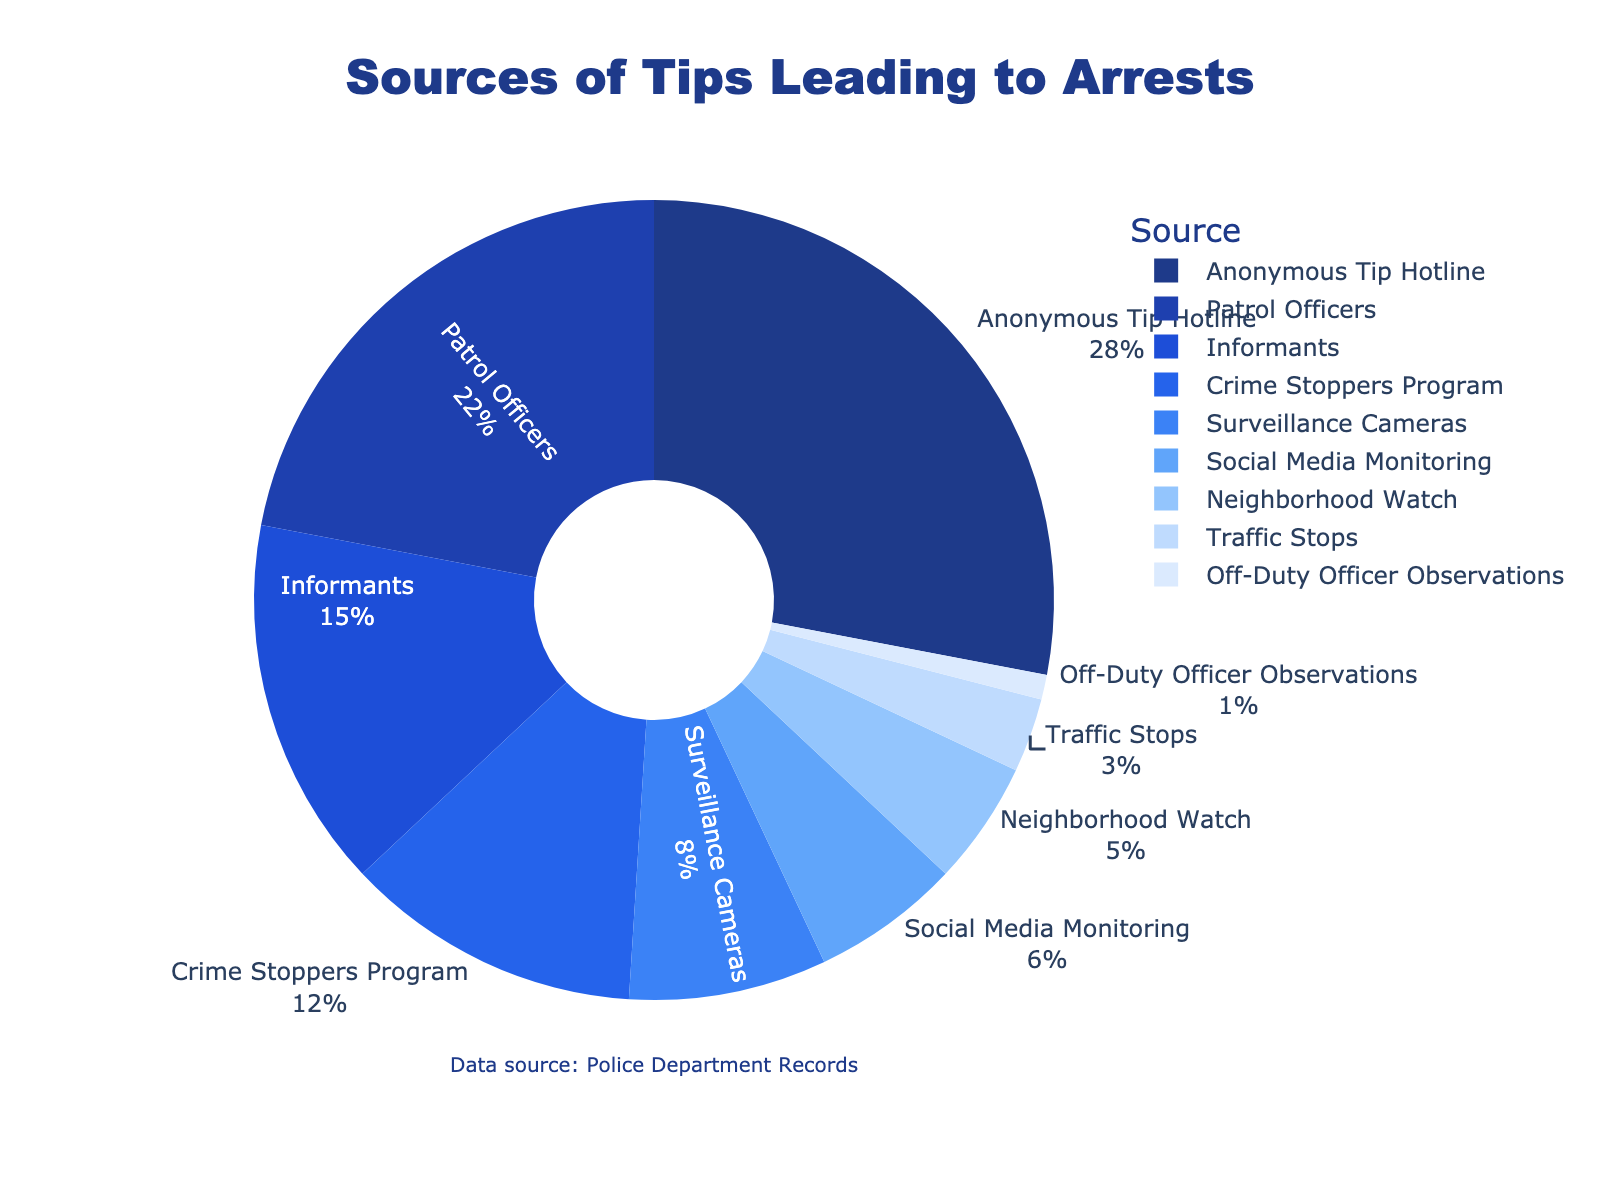Which source provides the most tips leading to arrests? The source with the highest percentage in the pie chart is the Anonymous Tip Hotline at 28%.
Answer: Anonymous Tip Hotline How much higher is the percentage of tips from Patrol Officers compared to Traffic Stops? The percentage for Patrol Officers is 22%, and for Traffic Stops, it is 3%. The difference is calculated as 22% - 3%.
Answer: 19% What is the combined percentage of tips from Surveillance Cameras and Social Media Monitoring? The percentage for Surveillance Cameras is 8%, and for Social Media Monitoring, it is 6%. The combined percentage is 8% + 6%.
Answer: 14% Which sources contribute the least to tips leading to arrests? The smallest percentages in the chart are Off-Duty Officer Observations at 1% and Traffic Stops at 3%.
Answer: Off-Duty Officer Observations and Traffic Stops Are tips from Informants greater than those from Social Media Monitoring and Neighborhood Watch combined? Tips from Informants are 15%. The combined percentage for Social Media Monitoring (6%) and Neighborhood Watch (5%) is 6% + 5% = 11%. Since 15% is greater than 11%, Informants contribute more.
Answer: Yes What is the difference between the highest and lowest sources of tips? The highest source is Anonymous Tip Hotline at 28%, and the lowest is Off-Duty Officer Observations at 1%. The difference is calculated as 28% - 1%.
Answer: 27% Do combined contributions from Crime Stoppers Program and Neighborhood Watch exceed those from Patrol Officers? Crime Stoppers Program is at 12% and Neighborhood Watch is at 5%, their combined contribution is 12% + 5% = 17%. This is less than the 22% from Patrol Officers.
Answer: No How do the contributions of Patrol Officers and Anonymous Tip Hotline together compare to half of the total data? The total percentage contribution for Patrol Officers and Anonymous Tip Hotline is 22% + 28% = 50%. Half of the total data is 100% / 2 = 50%. Their contributions combined equal half of the total.
Answer: Equal What percentage of total tips do the top three sources contribute? The top three sources are Anonymous Tip Hotline (28%), Patrol Officers (22%), and Informants (15%). Their combined contribution is 28% + 22% + 15% = 65%.
Answer: 65% Is the percentage of tips coming from the Crime Stoppers Program and Surveillance Cameras together more or less than those from Informants? Crime Stoppers Program is at 12% and Surveillance Cameras at 8%, adding to 12% + 8% = 20%. This is greater than the 15% from Informants.
Answer: More 